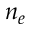Convert formula to latex. <formula><loc_0><loc_0><loc_500><loc_500>n _ { e }</formula> 